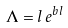Convert formula to latex. <formula><loc_0><loc_0><loc_500><loc_500>\Lambda = l \, e ^ { b l }</formula> 